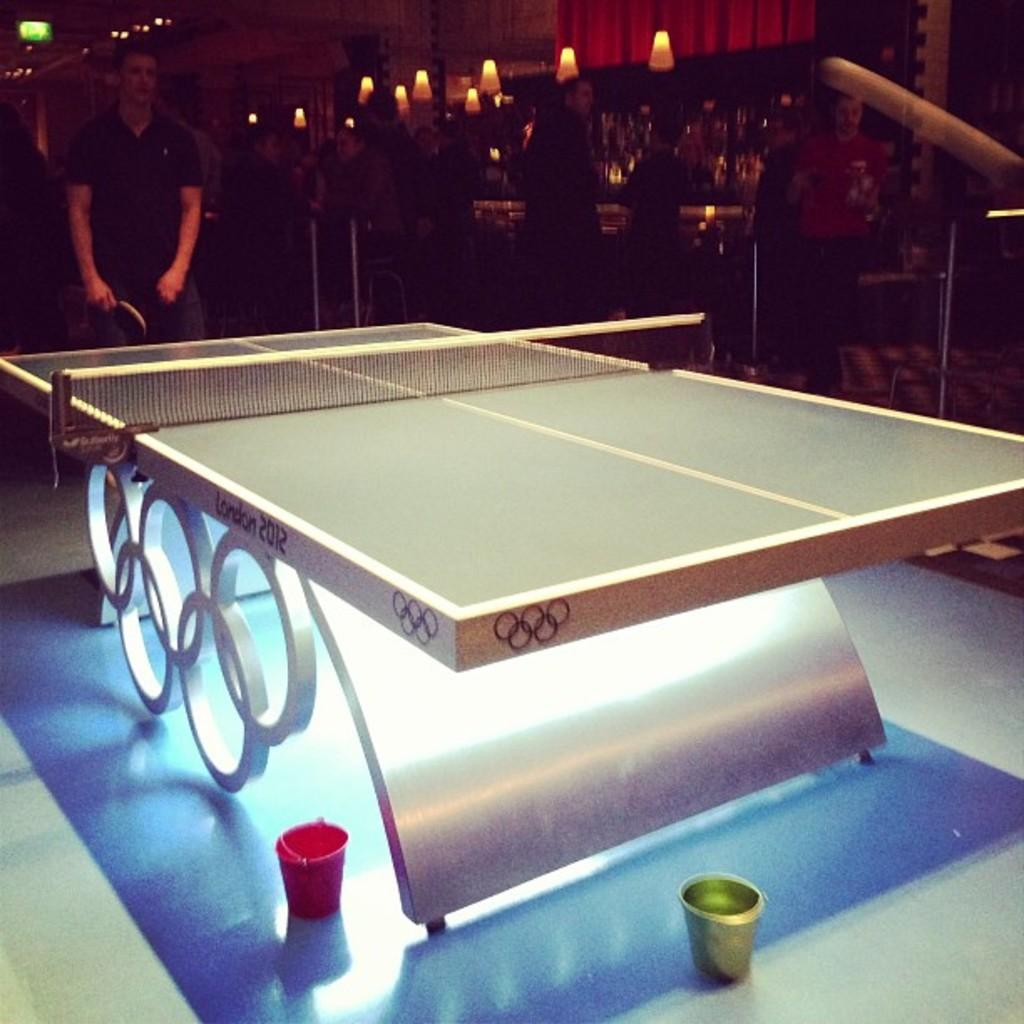What is the main object in the image? There is a table tennis board in the image. Who is present in the image? A person is standing behind the table tennis board, and there are other people standing in the image. What can be seen in the background or surrounding area? There are lights visible in the image. What type of quince is being used as a ball in the table tennis game? There is no quince present in the image, and table tennis is typically played with a small, lightweight ball made of celluloid or similar material. 